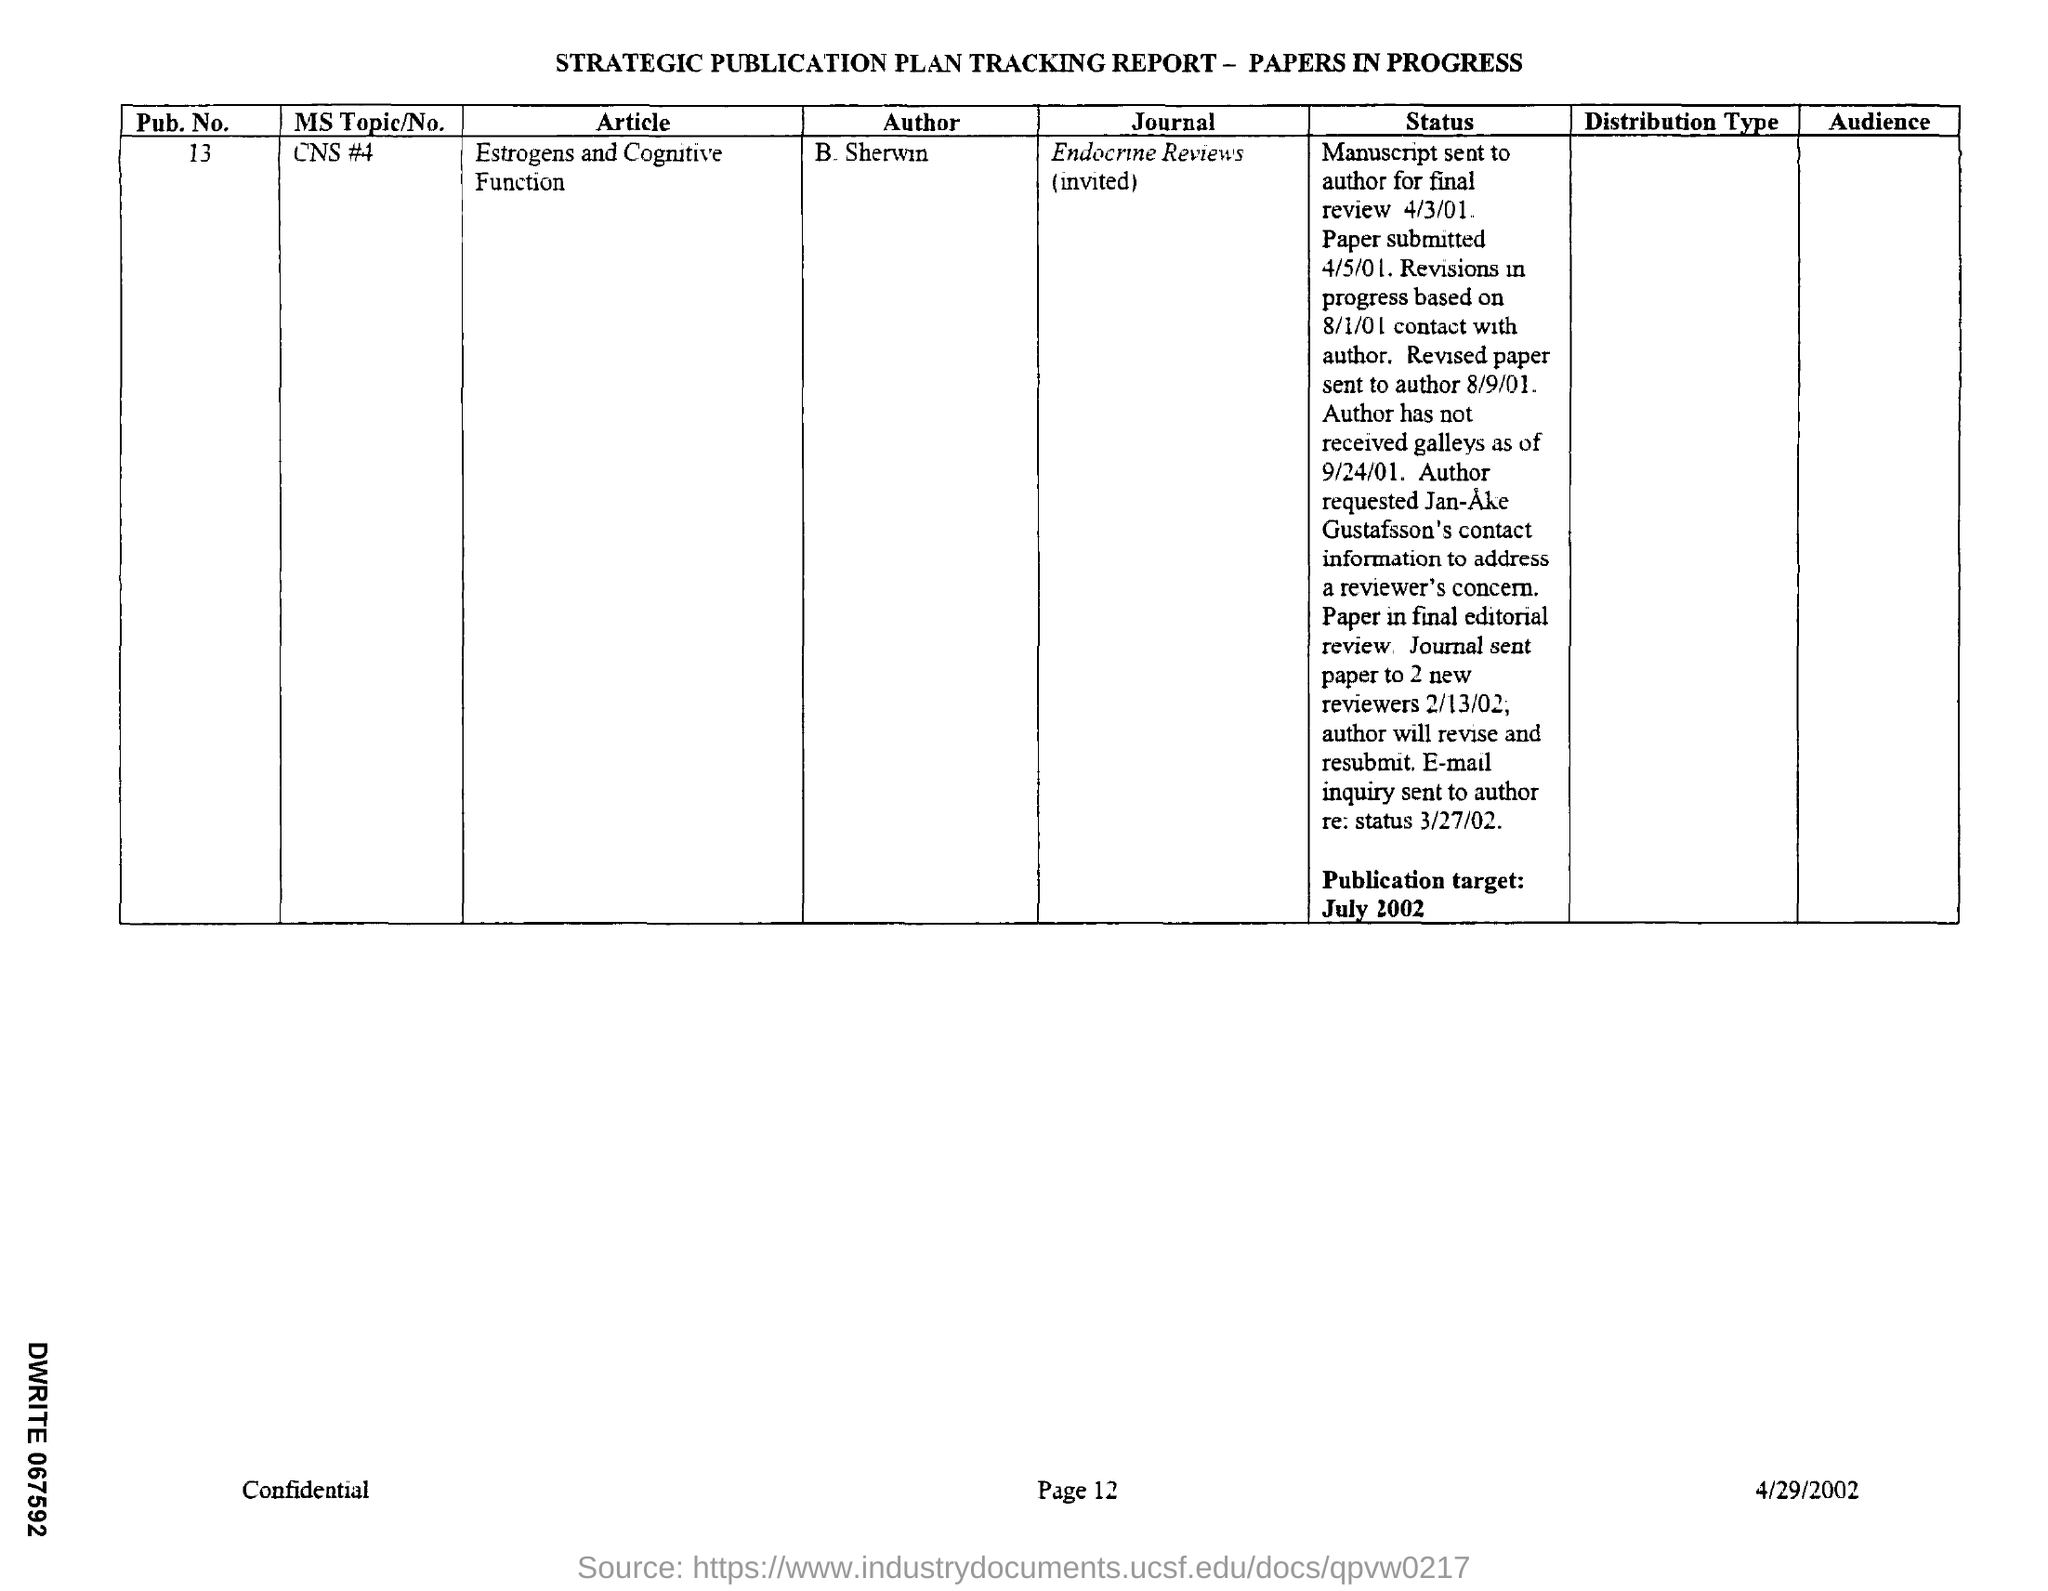Highlight a few significant elements in this photo. What is the MS topic/no mention in the given report? CNS #4. The article titled 'Estrogens and Cognitive Function' is mentioned in the given report. The report mentions a pub.no. of 13. 